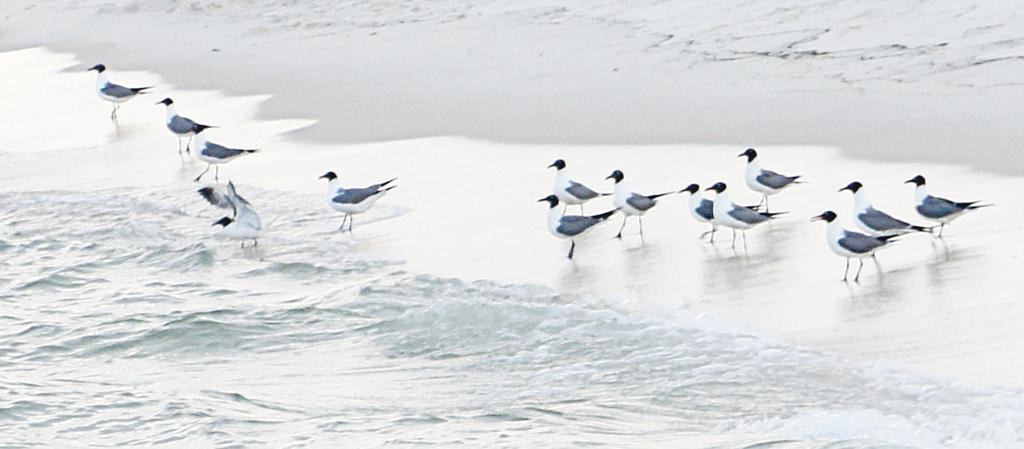What type of animals can be seen on the ground in the image? There are birds on the ground in the image. Where else can birds be seen in the image? Birds can also be seen in the water in the image. What type of building can be seen in the image? There is no building present in the image; it features birds on the ground and in the water. Can you see any cobwebs in the image? There are no cobwebs present in the image. 